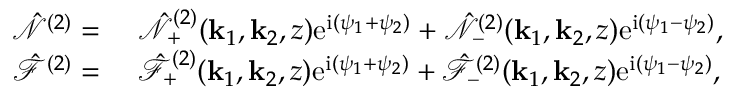Convert formula to latex. <formula><loc_0><loc_0><loc_500><loc_500>\begin{array} { r l } { \hat { \mathcal { N } } ^ { ( 2 ) } = } & { \hat { \mathcal { N } } _ { + } ^ { ( 2 ) } ( k _ { 1 } , k _ { 2 } , z ) e ^ { i ( \psi _ { 1 } + \psi _ { 2 } ) } + \hat { \mathcal { N } } _ { - } ^ { ( 2 ) } ( k _ { 1 } , k _ { 2 } , z ) e ^ { i ( \psi _ { 1 } - \psi _ { 2 } ) } , } \\ { \hat { \mathcal { F } } ^ { ( 2 ) } = } & { \hat { \mathcal { F } } _ { + } ^ { ( 2 ) } ( k _ { 1 } , k _ { 2 } , z ) e ^ { i ( \psi _ { 1 } + \psi _ { 2 } ) } + \hat { \mathcal { F } } _ { - } ^ { ( 2 ) } ( k _ { 1 } , k _ { 2 } , z ) e ^ { i ( \psi _ { 1 } - \psi _ { 2 } ) } , } \end{array}</formula> 